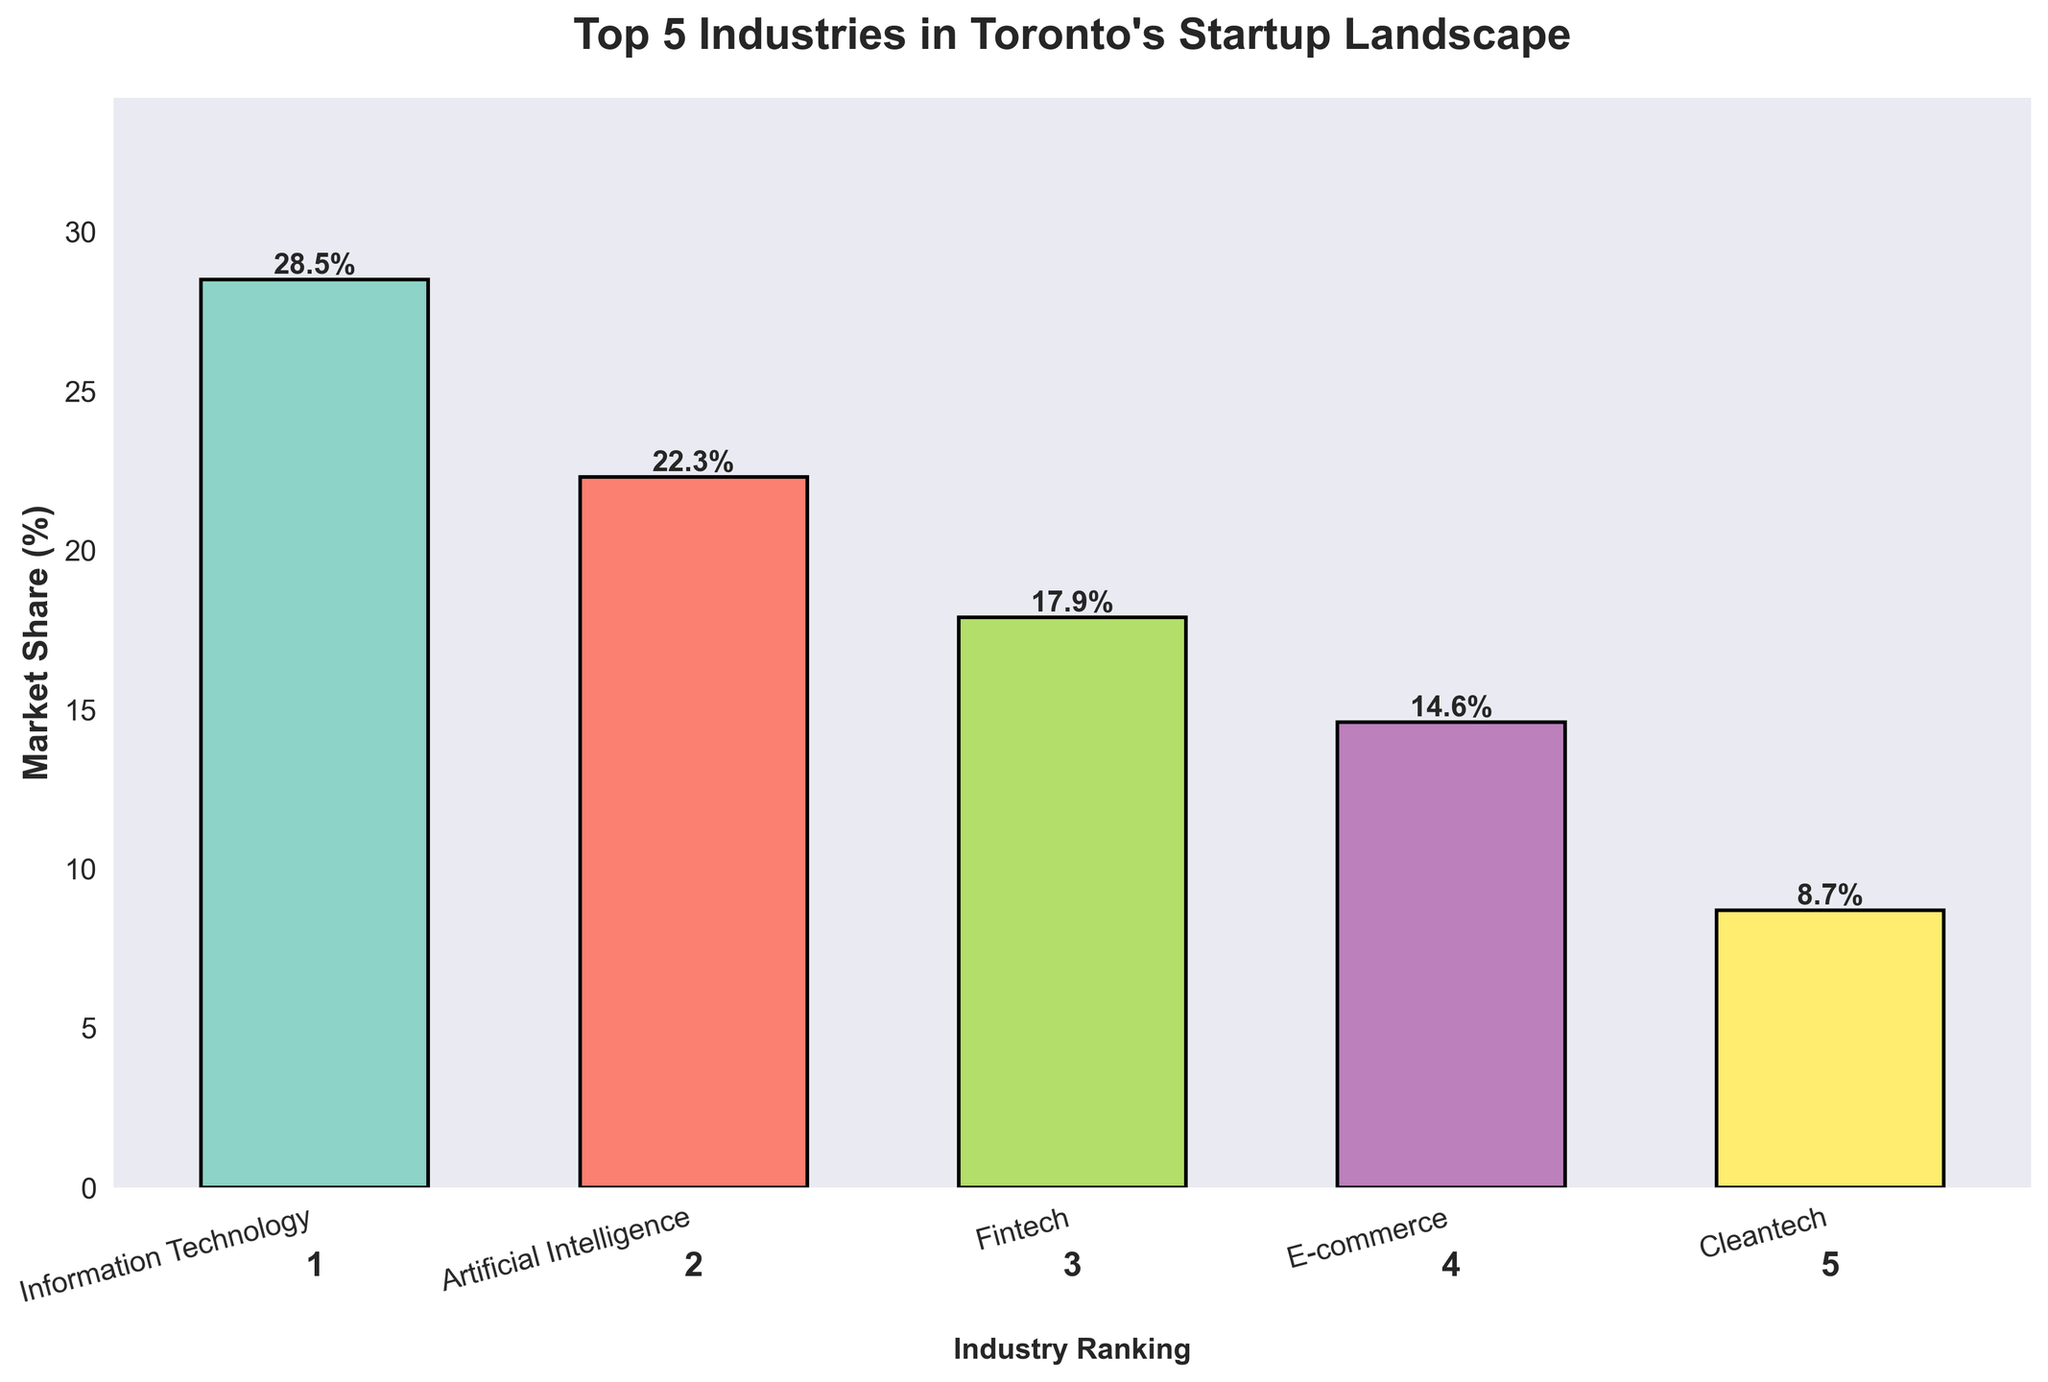Which industry has the highest market share? Look at the bar with the greatest height and read the label. The tallest bar corresponds to Information Technology with a market share of 28.5%.
Answer: Information Technology How much market share does Artificial Intelligence have? Locate the bar labeled "Artificial Intelligence" and read the value annotated at the top of the bar. The value is 22.3%.
Answer: 22.3% Which industry has a market share closest to 15%? Compare the market share values of each industry to 15%. E-commerce has a market share of 14.6%, which is closest to 15%.
Answer: E-commerce What is the sum of the market shares of the Information Technology and Fintech industries? Add the market share values of Information Technology (28.5%) and Fintech (17.9%). The sum is 28.5 + 17.9 = 46.4%.
Answer: 46.4% Which industry has the smallest market share and what is its value? Identify the shortest bar, which represents Cleantech with a market share of 8.7%.
Answer: Cleantech, 8.7% What is the difference in market share between the top industry and the lowest industry? Subtract the market share of Cleantech (8.7%) from Information Technology (28.5%). The difference is 28.5 - 8.7 = 19.8%.
Answer: 19.8% Rank the industries from highest to lowest market share. Order the industry names based on the heights of their bars from tallest to shortest. The ranking is: Information Technology (28.5%), Artificial Intelligence (22.3%), Fintech (17.9%), E-commerce (14.6%), Cleantech (8.7%).
Answer: Information Technology, Artificial Intelligence, Fintech, E-commerce, Cleantech Combining the market shares of Artificial Intelligence and E-commerce, how does their total compare to that of Information Technology? Add the market shares of Artificial Intelligence (22.3%) and E-commerce (14.6%). The total is 22.3 + 14.6 = 36.9%. Compare this to Information Technology's market share of 28.5%. Since 36.9% > 28.5%, the combined market share is greater.
Answer: The combined market share is greater What is the average market share of the top 3 industries? Add the market shares of the top 3 industries: Information Technology (28.5%), Artificial Intelligence (22.3%), and Fintech (17.9%). The sum is 28.5 + 22.3 + 17.9 = 68.7%. Divide by 3 to find the average: 68.7 / 3 ≈ 22.9%.
Answer: 22.9% What is the visual difference between the bars representing Fintech and Cleantech? Compare the heights of the bars representing Fintech and Cleantech. The Fintech bar is significantly taller, denoting a larger market share, whereas the Cleantech bar is much shorter.
Answer: Fintech bar is significantly taller than Cleantech bar 